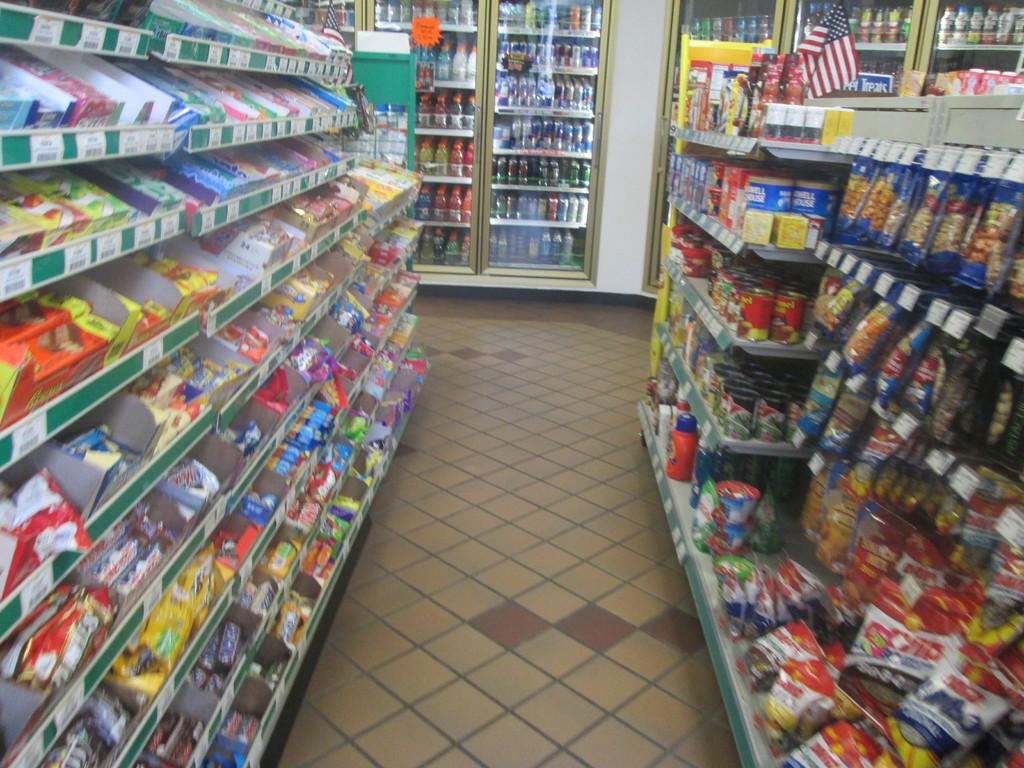What can be seen on the shelves in the image? Consumer goods are placed on shelves in the image. What type of appliances are visible in the background? There are refrigerators in the background of the image. What items can be found inside the refrigerators? Bottles, tins, and drinks are present in the refrigerators. How does the support beam hold up the shelves in the image? There is no support beam visible in the image, and the shelves appear to be freestanding or attached to a wall. 